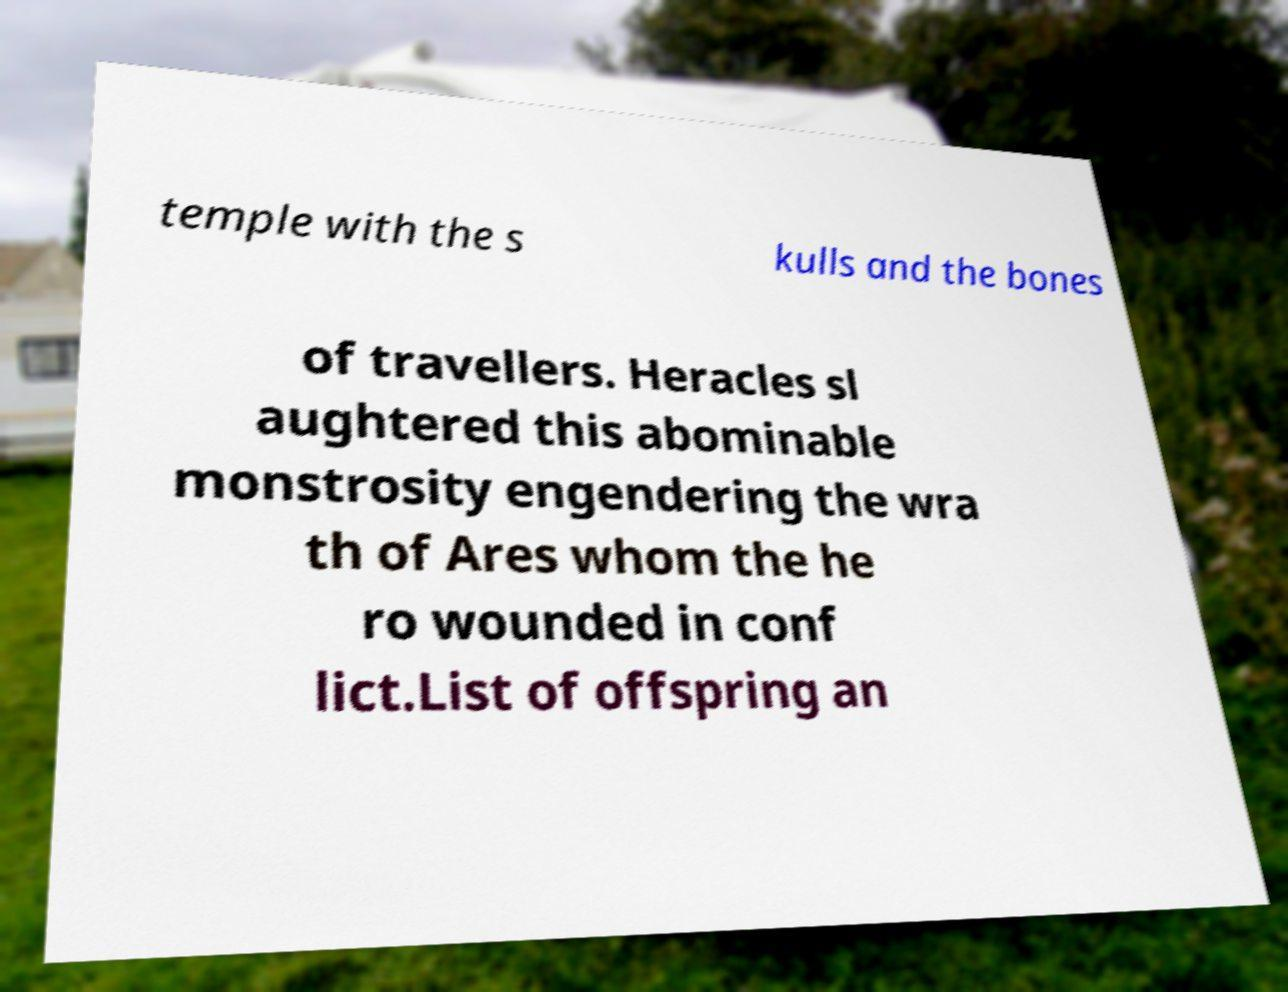Can you read and provide the text displayed in the image?This photo seems to have some interesting text. Can you extract and type it out for me? temple with the s kulls and the bones of travellers. Heracles sl aughtered this abominable monstrosity engendering the wra th of Ares whom the he ro wounded in conf lict.List of offspring an 